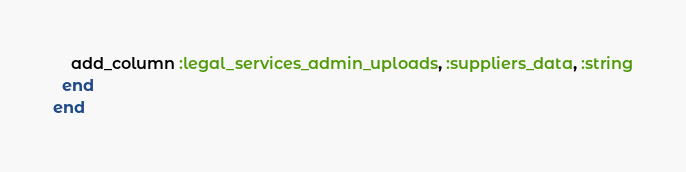<code> <loc_0><loc_0><loc_500><loc_500><_Ruby_>    add_column :legal_services_admin_uploads, :suppliers_data, :string
  end
end
</code> 